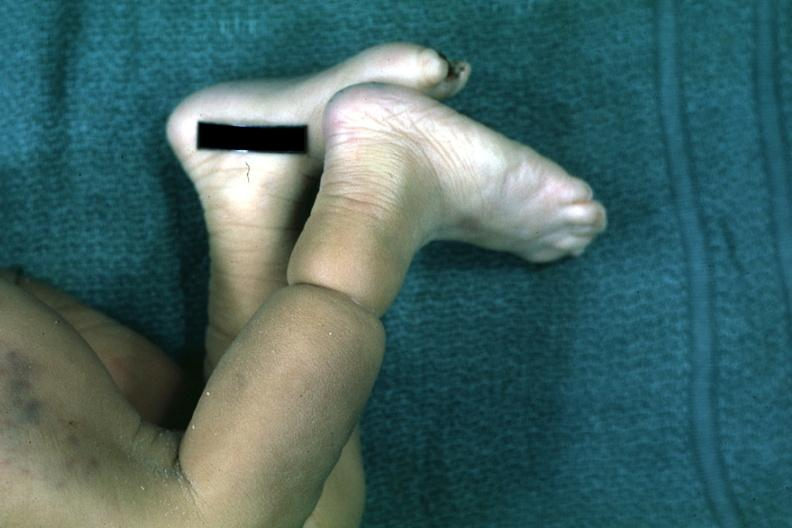what does this image show?
Answer the question using a single word or phrase. Called streeters band whatever that is looks like an amniotic band lesion 